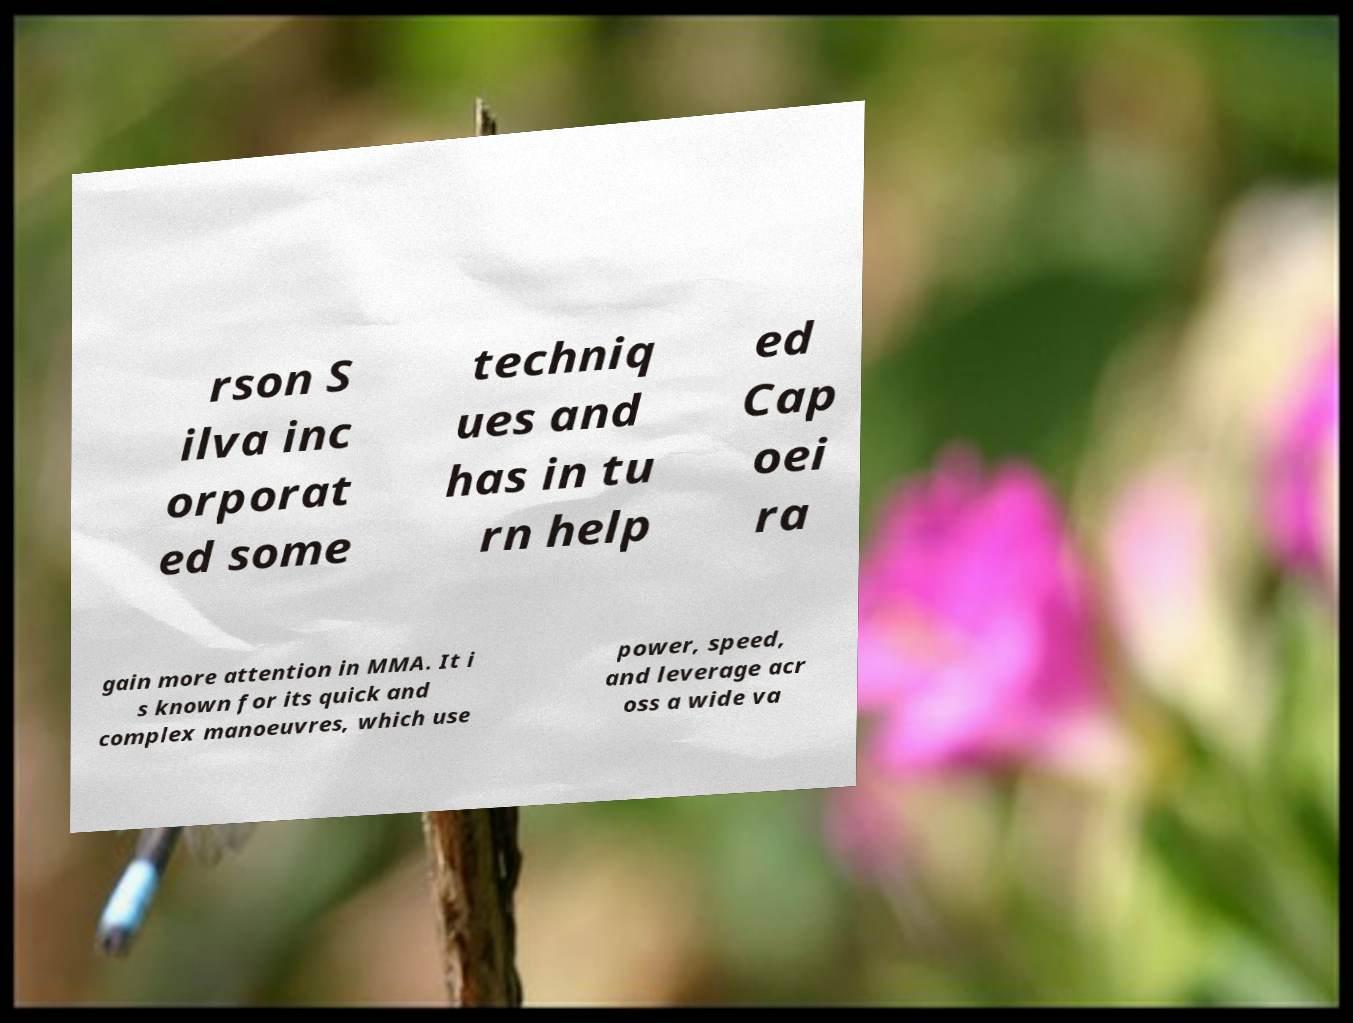I need the written content from this picture converted into text. Can you do that? rson S ilva inc orporat ed some techniq ues and has in tu rn help ed Cap oei ra gain more attention in MMA. It i s known for its quick and complex manoeuvres, which use power, speed, and leverage acr oss a wide va 